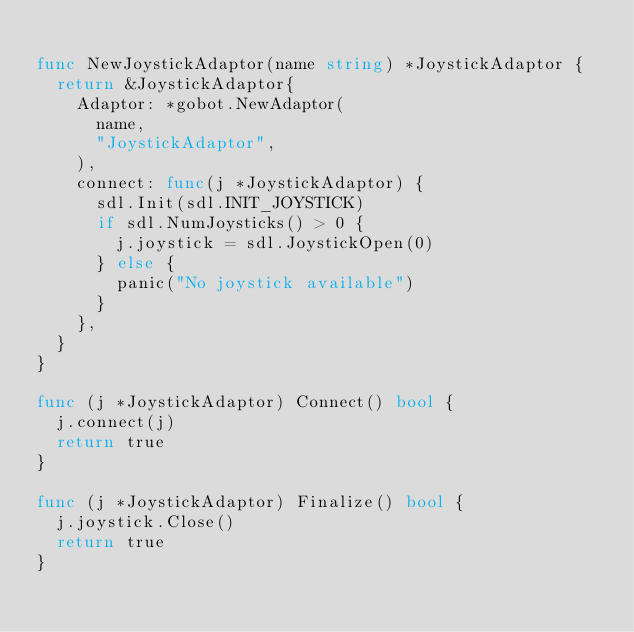Convert code to text. <code><loc_0><loc_0><loc_500><loc_500><_Go_>
func NewJoystickAdaptor(name string) *JoystickAdaptor {
	return &JoystickAdaptor{
		Adaptor: *gobot.NewAdaptor(
			name,
			"JoystickAdaptor",
		),
		connect: func(j *JoystickAdaptor) {
			sdl.Init(sdl.INIT_JOYSTICK)
			if sdl.NumJoysticks() > 0 {
				j.joystick = sdl.JoystickOpen(0)
			} else {
				panic("No joystick available")
			}
		},
	}
}

func (j *JoystickAdaptor) Connect() bool {
	j.connect(j)
	return true
}

func (j *JoystickAdaptor) Finalize() bool {
	j.joystick.Close()
	return true
}
</code> 